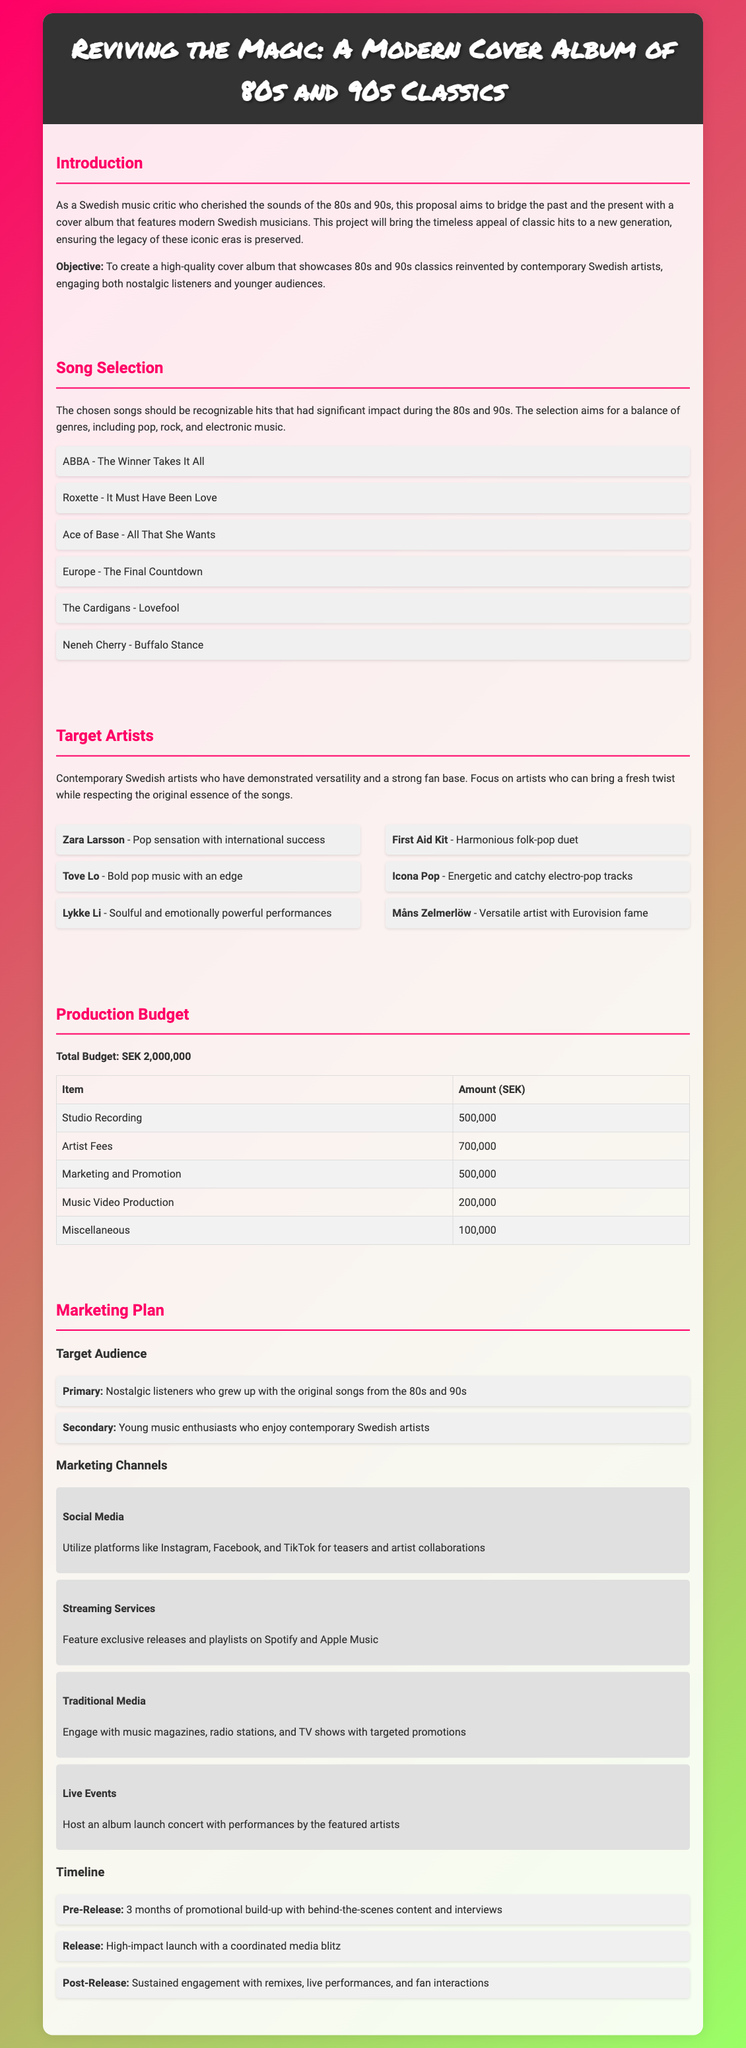What is the title of the proposal? The title is presented prominently at the top of the document.
Answer: Reviving the Magic: A Modern Cover Album of 80s and 90s Classics What is the total budget for the project? The budget is clearly outlined in the production budget section.
Answer: SEK 2,000,000 Which song by ABBA is included in the song selection? The song selection lists recognized hits, including one from ABBA.
Answer: The Winner Takes It All Who is a contemporary artist known for bold pop music? The target artists section includes descriptions of each artist's style.
Answer: Tove Lo What is the primary target audience for the marketing plan? The target audience is specified in the marketing plan section under Primary.
Answer: Nostalgic listeners How many months of promotional build-up is planned before the release? The timeline section outlines the promotional efforts prior to the album's release.
Answer: 3 months What type of event is planned for the album launch? The marketing plan describes a specific type of event for showcasing the album.
Answer: An album launch concert What is the budget allocated for marketing and promotion? The production budget table specifies the amount for marketing and promotion.
Answer: 500,000 Which social media platforms are mentioned for marketing? The marketing channels include various platforms outlined for promotional use.
Answer: Instagram, Facebook, and TikTok 